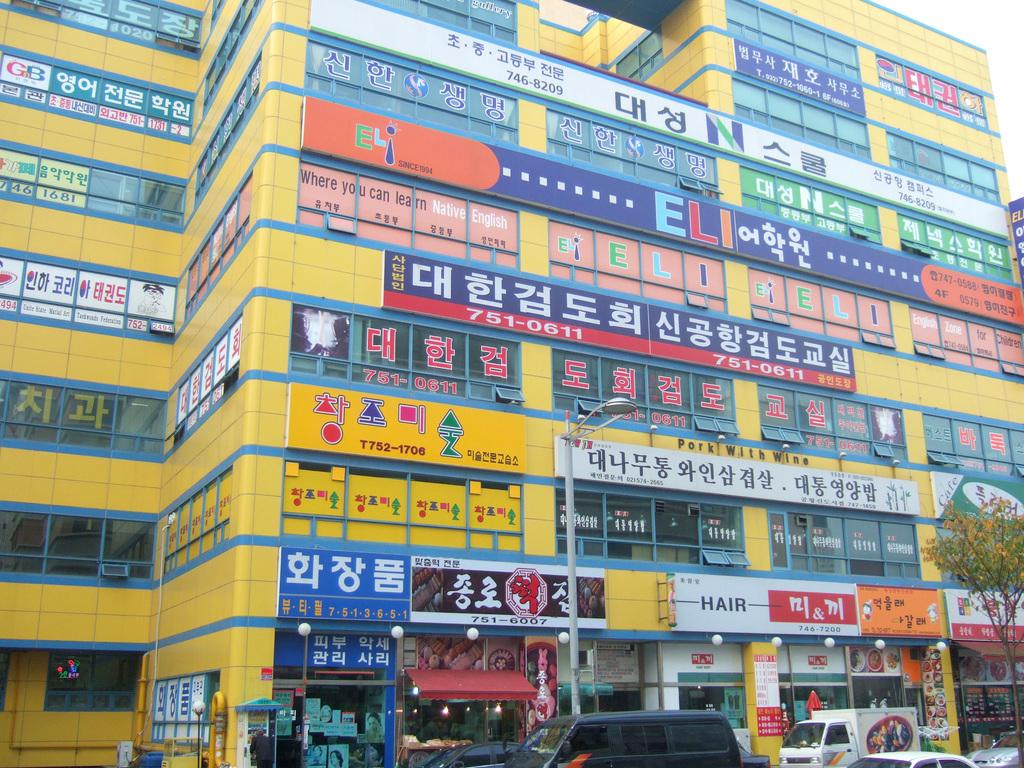What type of structure is visible in the image? There is a building in the image. What can be seen on the building in the image? There are hoardings on the building in the image. What is illuminated in the image? There are lights in the image. What type of plant is present in the image? There is a tree in the image. What is the tall, vertical object in the image? There is a pole in the image. What is in front of the building in the image? There are vehicles in front of the building in the image. What month is it in the image? The month cannot be determined from the image, as it does not contain any information about the time of year. 